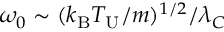<formula> <loc_0><loc_0><loc_500><loc_500>\omega _ { 0 } \sim ( k _ { B } T _ { U } / m ) ^ { 1 / 2 } / \lambda _ { C }</formula> 